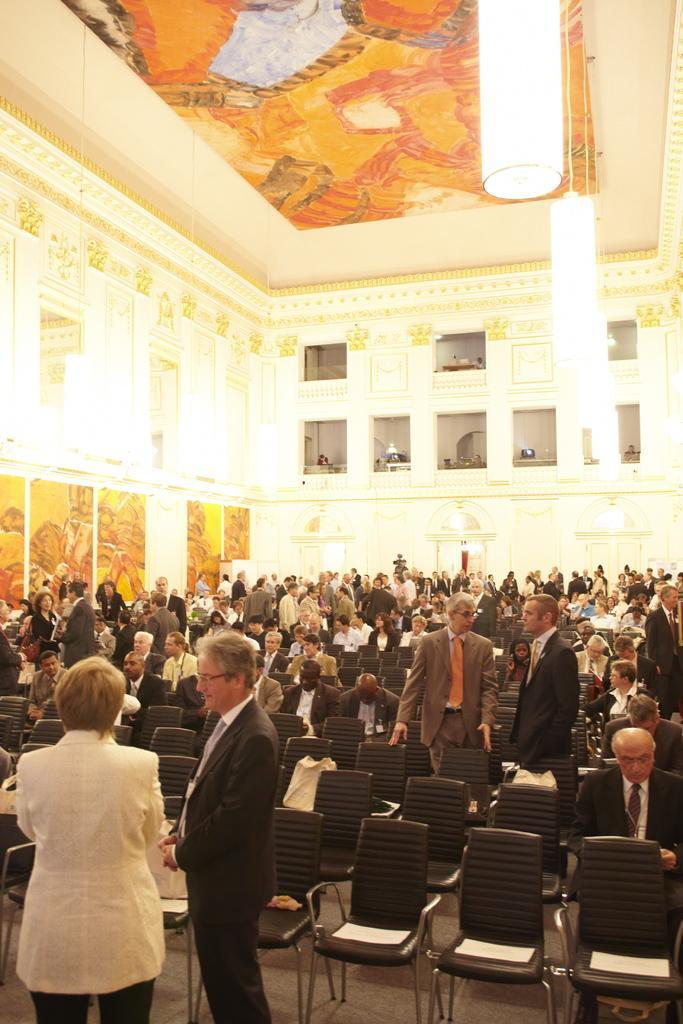In one or two sentences, can you explain what this image depicts? As we can see in the image there is a wall, few people standing and sitting on chairs. 